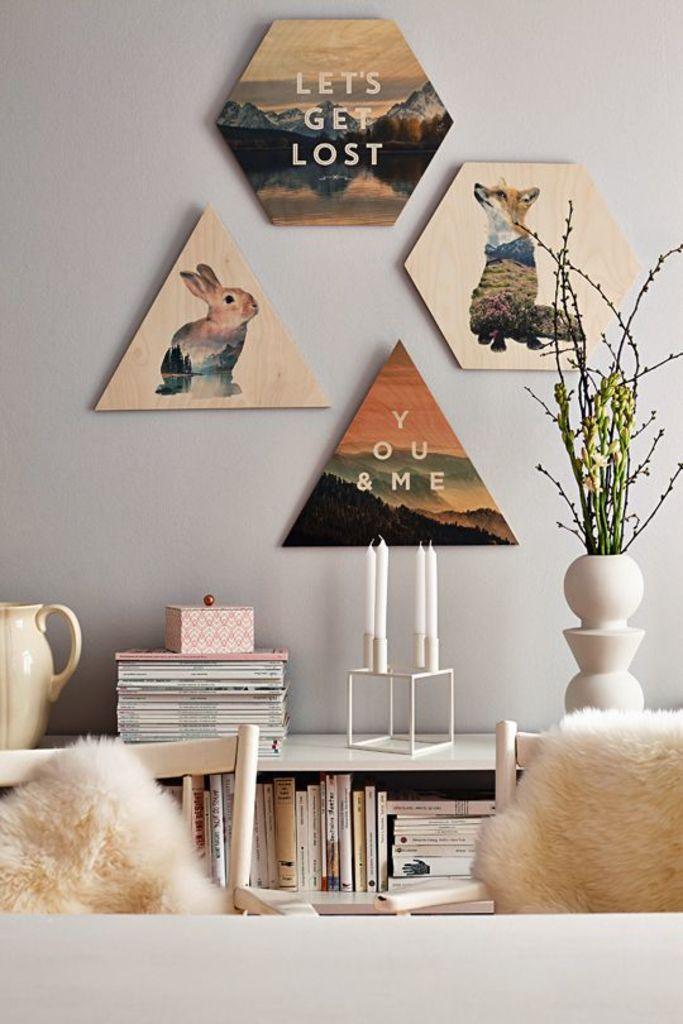Describe this image in one or two sentences. In this image we can see the frames are attached to the wall and books are arranged in the cupboard. On the top of the cupboard, we can see flower vase, candle stand, books, box and jar. There are chairs at the bottom of the image. 